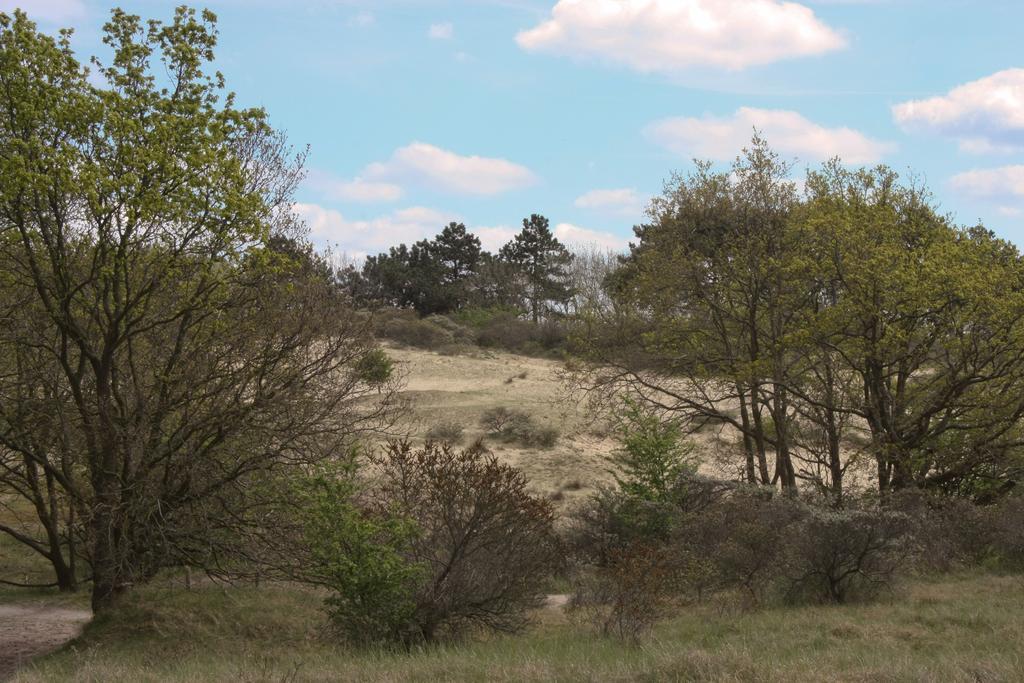Please provide a concise description of this image. In this image, we can see some grass and plants. We can see the ground. There are a few trees. We can see the sky with clouds. 